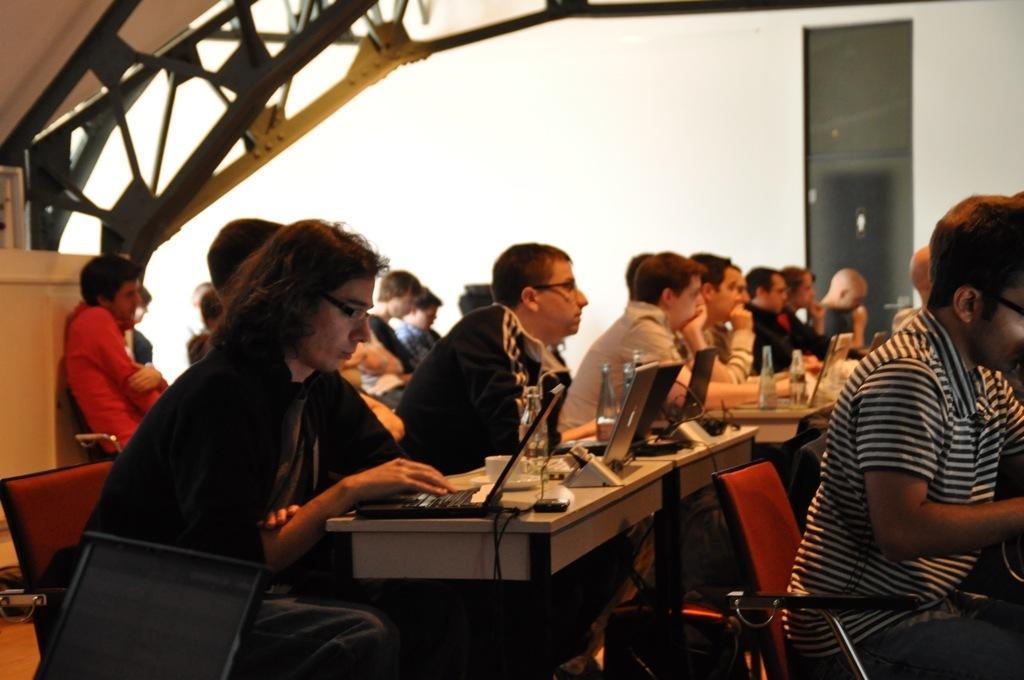Please provide a concise description of this image. This image is clicked in a room. There are many persons sitting in the chairs and using laptops. To the right, the man sitting in the chair is wearing black and white shirt. To the left, the woman sitting in a chair is using laptop. In the background, there are rods and walls. 